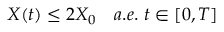Convert formula to latex. <formula><loc_0><loc_0><loc_500><loc_500>X ( t ) \leq 2 X _ { 0 } \quad a . e . \ t \in [ 0 , T ]</formula> 